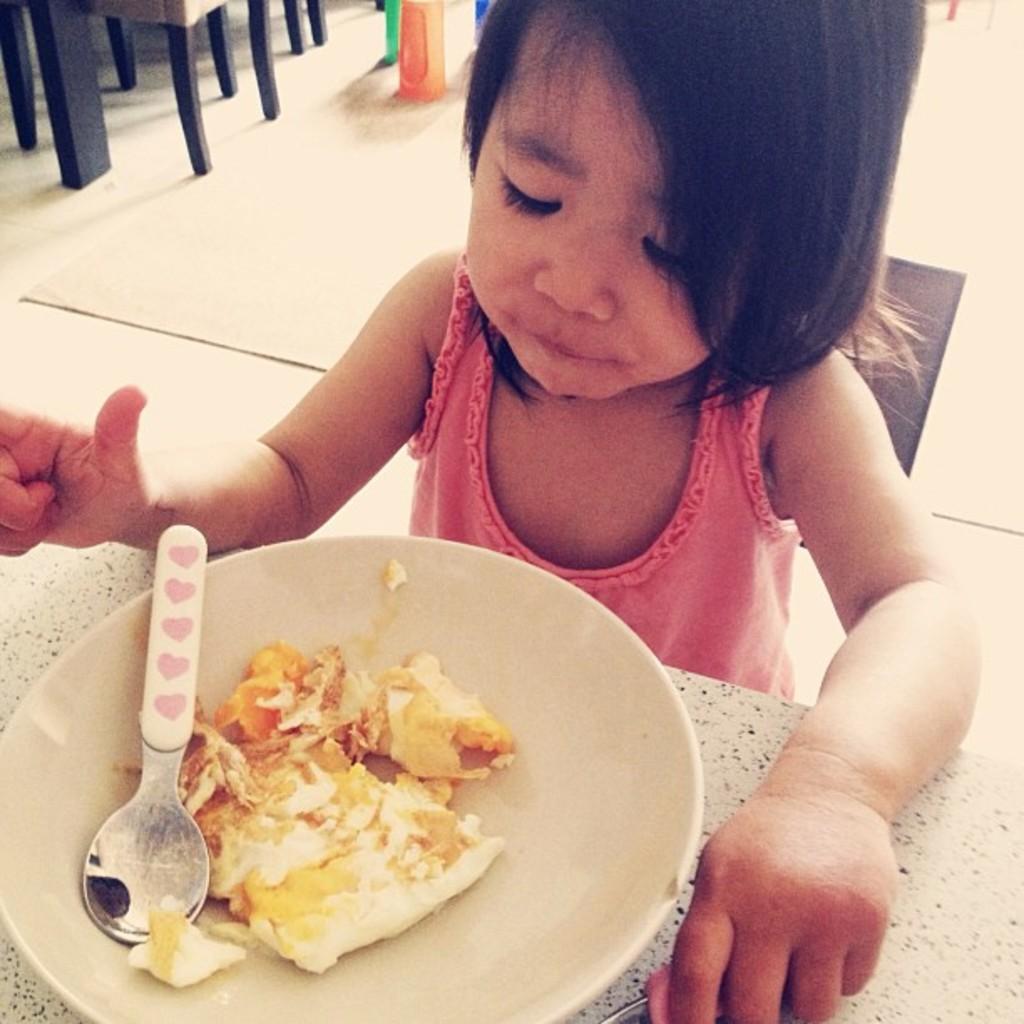Can you describe this image briefly? In this image we can see a kid near the table holding an object, there is a plate with food item and a spoon on the table and there are few objects on the floor in the background. 